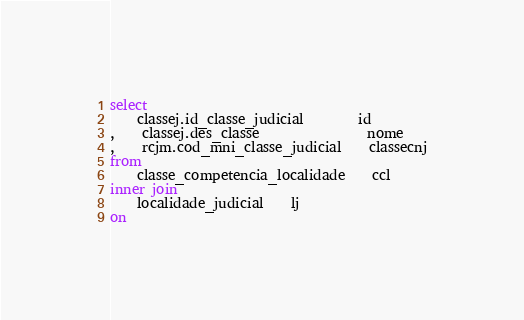<code> <loc_0><loc_0><loc_500><loc_500><_SQL_>select
	classej.id_classe_judicial		id
,	classej.des_classe				nome
,	rcjm.cod_mni_classe_judicial	classecnj
from
	classe_competencia_localidade	ccl
inner join
	localidade_judicial	lj
on</code> 